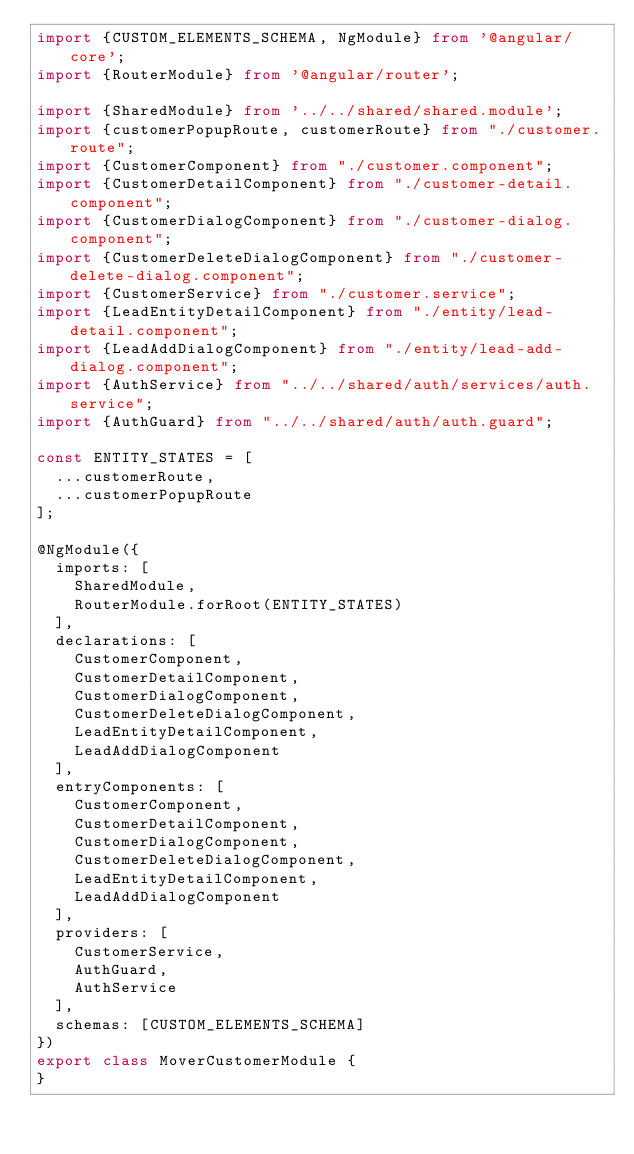<code> <loc_0><loc_0><loc_500><loc_500><_TypeScript_>import {CUSTOM_ELEMENTS_SCHEMA, NgModule} from '@angular/core';
import {RouterModule} from '@angular/router';

import {SharedModule} from '../../shared/shared.module';
import {customerPopupRoute, customerRoute} from "./customer.route";
import {CustomerComponent} from "./customer.component";
import {CustomerDetailComponent} from "./customer-detail.component";
import {CustomerDialogComponent} from "./customer-dialog.component";
import {CustomerDeleteDialogComponent} from "./customer-delete-dialog.component";
import {CustomerService} from "./customer.service";
import {LeadEntityDetailComponent} from "./entity/lead-detail.component";
import {LeadAddDialogComponent} from "./entity/lead-add-dialog.component";
import {AuthService} from "../../shared/auth/services/auth.service";
import {AuthGuard} from "../../shared/auth/auth.guard";

const ENTITY_STATES = [
  ...customerRoute,
  ...customerPopupRoute
];

@NgModule({
  imports: [
    SharedModule,
    RouterModule.forRoot(ENTITY_STATES)
  ],
  declarations: [
    CustomerComponent,
    CustomerDetailComponent,
    CustomerDialogComponent,
    CustomerDeleteDialogComponent,
    LeadEntityDetailComponent,
    LeadAddDialogComponent
  ],
  entryComponents: [
    CustomerComponent,
    CustomerDetailComponent,
    CustomerDialogComponent,
    CustomerDeleteDialogComponent,
    LeadEntityDetailComponent,
    LeadAddDialogComponent
  ],
  providers: [
    CustomerService,
    AuthGuard,
    AuthService
  ],
  schemas: [CUSTOM_ELEMENTS_SCHEMA]
})
export class MoverCustomerModule {
}
</code> 